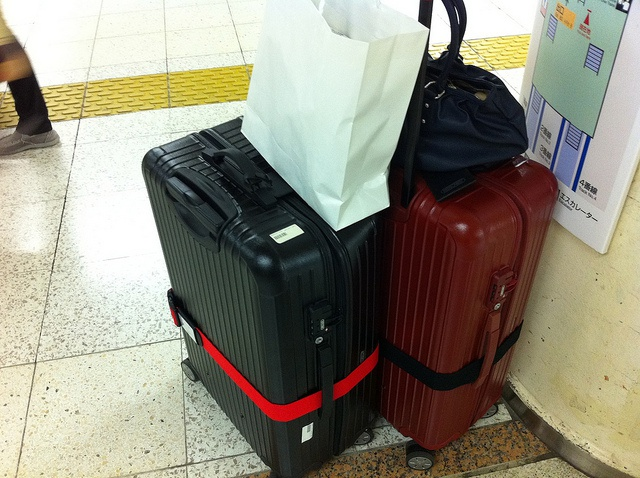Describe the objects in this image and their specific colors. I can see suitcase in beige, black, and gray tones, suitcase in beige, maroon, black, and gray tones, handbag in beige, lightblue, lightgray, and darkgray tones, backpack in beige, black, white, gray, and darkgray tones, and handbag in beige, black, gray, ivory, and darkgray tones in this image. 